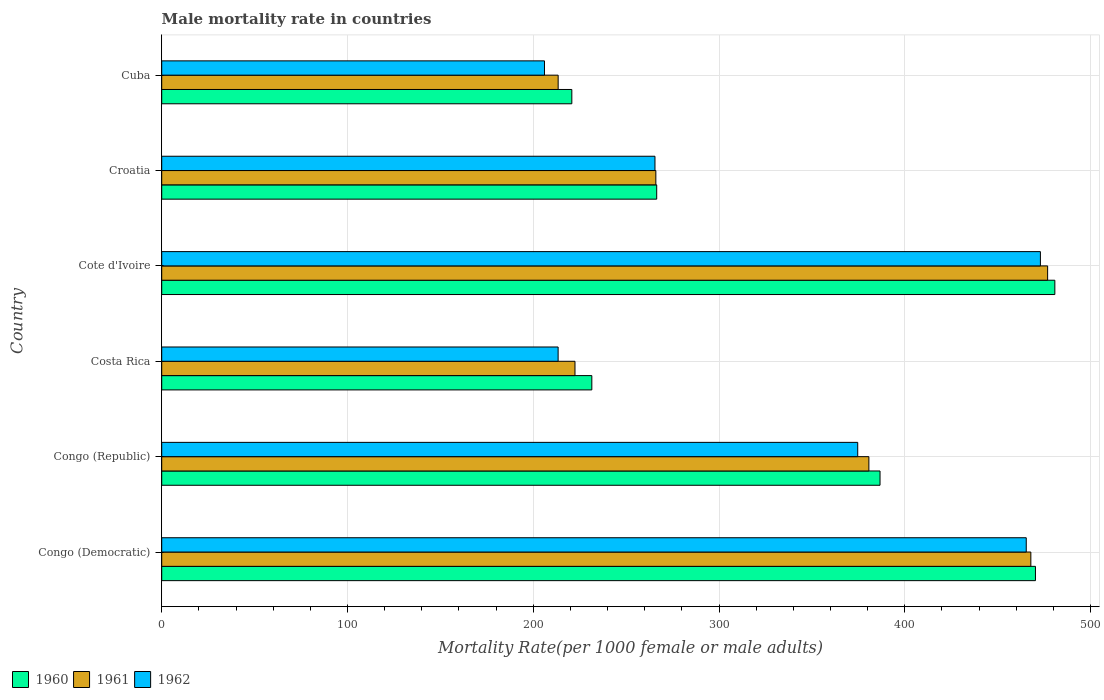How many groups of bars are there?
Make the answer very short. 6. Are the number of bars per tick equal to the number of legend labels?
Your answer should be very brief. Yes. What is the label of the 5th group of bars from the top?
Make the answer very short. Congo (Republic). What is the male mortality rate in 1962 in Congo (Republic)?
Keep it short and to the point. 374.66. Across all countries, what is the maximum male mortality rate in 1961?
Ensure brevity in your answer.  476.88. Across all countries, what is the minimum male mortality rate in 1960?
Your answer should be very brief. 220.76. In which country was the male mortality rate in 1960 maximum?
Your answer should be compact. Cote d'Ivoire. In which country was the male mortality rate in 1960 minimum?
Offer a very short reply. Cuba. What is the total male mortality rate in 1960 in the graph?
Your answer should be very brief. 2056.51. What is the difference between the male mortality rate in 1960 in Congo (Democratic) and that in Congo (Republic)?
Make the answer very short. 83.66. What is the difference between the male mortality rate in 1961 in Cote d'Ivoire and the male mortality rate in 1962 in Costa Rica?
Your answer should be very brief. 263.49. What is the average male mortality rate in 1961 per country?
Make the answer very short. 337.87. What is the difference between the male mortality rate in 1960 and male mortality rate in 1961 in Congo (Democratic)?
Provide a succinct answer. 2.48. What is the ratio of the male mortality rate in 1960 in Congo (Republic) to that in Costa Rica?
Keep it short and to the point. 1.67. Is the difference between the male mortality rate in 1960 in Congo (Democratic) and Cote d'Ivoire greater than the difference between the male mortality rate in 1961 in Congo (Democratic) and Cote d'Ivoire?
Keep it short and to the point. No. What is the difference between the highest and the second highest male mortality rate in 1961?
Provide a succinct answer. 9.03. What is the difference between the highest and the lowest male mortality rate in 1962?
Keep it short and to the point. 266.95. In how many countries, is the male mortality rate in 1962 greater than the average male mortality rate in 1962 taken over all countries?
Your response must be concise. 3. What does the 3rd bar from the bottom in Congo (Democratic) represents?
Your answer should be compact. 1962. Is it the case that in every country, the sum of the male mortality rate in 1961 and male mortality rate in 1960 is greater than the male mortality rate in 1962?
Your answer should be compact. Yes. Does the graph contain grids?
Offer a very short reply. Yes. How many legend labels are there?
Offer a very short reply. 3. How are the legend labels stacked?
Your answer should be very brief. Horizontal. What is the title of the graph?
Your response must be concise. Male mortality rate in countries. Does "2010" appear as one of the legend labels in the graph?
Provide a succinct answer. No. What is the label or title of the X-axis?
Keep it short and to the point. Mortality Rate(per 1000 female or male adults). What is the Mortality Rate(per 1000 female or male adults) in 1960 in Congo (Democratic)?
Provide a succinct answer. 470.33. What is the Mortality Rate(per 1000 female or male adults) of 1961 in Congo (Democratic)?
Your answer should be compact. 467.85. What is the Mortality Rate(per 1000 female or male adults) in 1962 in Congo (Democratic)?
Give a very brief answer. 465.37. What is the Mortality Rate(per 1000 female or male adults) of 1960 in Congo (Republic)?
Ensure brevity in your answer.  386.67. What is the Mortality Rate(per 1000 female or male adults) in 1961 in Congo (Republic)?
Your response must be concise. 380.66. What is the Mortality Rate(per 1000 female or male adults) of 1962 in Congo (Republic)?
Give a very brief answer. 374.66. What is the Mortality Rate(per 1000 female or male adults) of 1960 in Costa Rica?
Offer a terse response. 231.53. What is the Mortality Rate(per 1000 female or male adults) of 1961 in Costa Rica?
Your answer should be very brief. 222.46. What is the Mortality Rate(per 1000 female or male adults) of 1962 in Costa Rica?
Offer a terse response. 213.38. What is the Mortality Rate(per 1000 female or male adults) of 1960 in Cote d'Ivoire?
Keep it short and to the point. 480.76. What is the Mortality Rate(per 1000 female or male adults) of 1961 in Cote d'Ivoire?
Your answer should be compact. 476.88. What is the Mortality Rate(per 1000 female or male adults) in 1962 in Cote d'Ivoire?
Ensure brevity in your answer.  473. What is the Mortality Rate(per 1000 female or male adults) in 1960 in Croatia?
Your response must be concise. 266.45. What is the Mortality Rate(per 1000 female or male adults) in 1961 in Croatia?
Give a very brief answer. 265.99. What is the Mortality Rate(per 1000 female or male adults) of 1962 in Croatia?
Your answer should be compact. 265.52. What is the Mortality Rate(per 1000 female or male adults) in 1960 in Cuba?
Provide a succinct answer. 220.76. What is the Mortality Rate(per 1000 female or male adults) of 1961 in Cuba?
Your answer should be very brief. 213.41. What is the Mortality Rate(per 1000 female or male adults) in 1962 in Cuba?
Make the answer very short. 206.05. Across all countries, what is the maximum Mortality Rate(per 1000 female or male adults) of 1960?
Offer a terse response. 480.76. Across all countries, what is the maximum Mortality Rate(per 1000 female or male adults) in 1961?
Your answer should be compact. 476.88. Across all countries, what is the maximum Mortality Rate(per 1000 female or male adults) in 1962?
Your answer should be compact. 473. Across all countries, what is the minimum Mortality Rate(per 1000 female or male adults) of 1960?
Give a very brief answer. 220.76. Across all countries, what is the minimum Mortality Rate(per 1000 female or male adults) of 1961?
Make the answer very short. 213.41. Across all countries, what is the minimum Mortality Rate(per 1000 female or male adults) in 1962?
Keep it short and to the point. 206.05. What is the total Mortality Rate(per 1000 female or male adults) in 1960 in the graph?
Your answer should be compact. 2056.51. What is the total Mortality Rate(per 1000 female or male adults) in 1961 in the graph?
Your response must be concise. 2027.24. What is the total Mortality Rate(per 1000 female or male adults) of 1962 in the graph?
Your answer should be compact. 1997.98. What is the difference between the Mortality Rate(per 1000 female or male adults) in 1960 in Congo (Democratic) and that in Congo (Republic)?
Give a very brief answer. 83.66. What is the difference between the Mortality Rate(per 1000 female or male adults) in 1961 in Congo (Democratic) and that in Congo (Republic)?
Give a very brief answer. 87.19. What is the difference between the Mortality Rate(per 1000 female or male adults) in 1962 in Congo (Democratic) and that in Congo (Republic)?
Your answer should be very brief. 90.71. What is the difference between the Mortality Rate(per 1000 female or male adults) in 1960 in Congo (Democratic) and that in Costa Rica?
Provide a succinct answer. 238.8. What is the difference between the Mortality Rate(per 1000 female or male adults) in 1961 in Congo (Democratic) and that in Costa Rica?
Offer a very short reply. 245.39. What is the difference between the Mortality Rate(per 1000 female or male adults) in 1962 in Congo (Democratic) and that in Costa Rica?
Make the answer very short. 251.99. What is the difference between the Mortality Rate(per 1000 female or male adults) of 1960 in Congo (Democratic) and that in Cote d'Ivoire?
Keep it short and to the point. -10.43. What is the difference between the Mortality Rate(per 1000 female or male adults) in 1961 in Congo (Democratic) and that in Cote d'Ivoire?
Provide a short and direct response. -9.03. What is the difference between the Mortality Rate(per 1000 female or male adults) in 1962 in Congo (Democratic) and that in Cote d'Ivoire?
Your answer should be very brief. -7.62. What is the difference between the Mortality Rate(per 1000 female or male adults) in 1960 in Congo (Democratic) and that in Croatia?
Make the answer very short. 203.88. What is the difference between the Mortality Rate(per 1000 female or male adults) in 1961 in Congo (Democratic) and that in Croatia?
Give a very brief answer. 201.87. What is the difference between the Mortality Rate(per 1000 female or male adults) in 1962 in Congo (Democratic) and that in Croatia?
Ensure brevity in your answer.  199.85. What is the difference between the Mortality Rate(per 1000 female or male adults) in 1960 in Congo (Democratic) and that in Cuba?
Your response must be concise. 249.57. What is the difference between the Mortality Rate(per 1000 female or male adults) in 1961 in Congo (Democratic) and that in Cuba?
Your answer should be very brief. 254.45. What is the difference between the Mortality Rate(per 1000 female or male adults) in 1962 in Congo (Democratic) and that in Cuba?
Make the answer very short. 259.32. What is the difference between the Mortality Rate(per 1000 female or male adults) in 1960 in Congo (Republic) and that in Costa Rica?
Your answer should be compact. 155.14. What is the difference between the Mortality Rate(per 1000 female or male adults) of 1961 in Congo (Republic) and that in Costa Rica?
Provide a succinct answer. 158.21. What is the difference between the Mortality Rate(per 1000 female or male adults) in 1962 in Congo (Republic) and that in Costa Rica?
Ensure brevity in your answer.  161.28. What is the difference between the Mortality Rate(per 1000 female or male adults) in 1960 in Congo (Republic) and that in Cote d'Ivoire?
Give a very brief answer. -94.09. What is the difference between the Mortality Rate(per 1000 female or male adults) in 1961 in Congo (Republic) and that in Cote d'Ivoire?
Your answer should be compact. -96.22. What is the difference between the Mortality Rate(per 1000 female or male adults) in 1962 in Congo (Republic) and that in Cote d'Ivoire?
Give a very brief answer. -98.34. What is the difference between the Mortality Rate(per 1000 female or male adults) of 1960 in Congo (Republic) and that in Croatia?
Provide a succinct answer. 120.21. What is the difference between the Mortality Rate(per 1000 female or male adults) in 1961 in Congo (Republic) and that in Croatia?
Offer a very short reply. 114.68. What is the difference between the Mortality Rate(per 1000 female or male adults) in 1962 in Congo (Republic) and that in Croatia?
Your response must be concise. 109.14. What is the difference between the Mortality Rate(per 1000 female or male adults) in 1960 in Congo (Republic) and that in Cuba?
Offer a terse response. 165.91. What is the difference between the Mortality Rate(per 1000 female or male adults) of 1961 in Congo (Republic) and that in Cuba?
Give a very brief answer. 167.26. What is the difference between the Mortality Rate(per 1000 female or male adults) in 1962 in Congo (Republic) and that in Cuba?
Your answer should be compact. 168.61. What is the difference between the Mortality Rate(per 1000 female or male adults) of 1960 in Costa Rica and that in Cote d'Ivoire?
Make the answer very short. -249.23. What is the difference between the Mortality Rate(per 1000 female or male adults) of 1961 in Costa Rica and that in Cote d'Ivoire?
Keep it short and to the point. -254.42. What is the difference between the Mortality Rate(per 1000 female or male adults) in 1962 in Costa Rica and that in Cote d'Ivoire?
Offer a terse response. -259.61. What is the difference between the Mortality Rate(per 1000 female or male adults) in 1960 in Costa Rica and that in Croatia?
Provide a succinct answer. -34.92. What is the difference between the Mortality Rate(per 1000 female or male adults) in 1961 in Costa Rica and that in Croatia?
Your answer should be very brief. -43.53. What is the difference between the Mortality Rate(per 1000 female or male adults) in 1962 in Costa Rica and that in Croatia?
Offer a very short reply. -52.13. What is the difference between the Mortality Rate(per 1000 female or male adults) of 1960 in Costa Rica and that in Cuba?
Keep it short and to the point. 10.77. What is the difference between the Mortality Rate(per 1000 female or male adults) in 1961 in Costa Rica and that in Cuba?
Give a very brief answer. 9.05. What is the difference between the Mortality Rate(per 1000 female or male adults) of 1962 in Costa Rica and that in Cuba?
Make the answer very short. 7.34. What is the difference between the Mortality Rate(per 1000 female or male adults) of 1960 in Cote d'Ivoire and that in Croatia?
Offer a terse response. 214.31. What is the difference between the Mortality Rate(per 1000 female or male adults) of 1961 in Cote d'Ivoire and that in Croatia?
Your answer should be compact. 210.89. What is the difference between the Mortality Rate(per 1000 female or male adults) of 1962 in Cote d'Ivoire and that in Croatia?
Your answer should be compact. 207.48. What is the difference between the Mortality Rate(per 1000 female or male adults) in 1960 in Cote d'Ivoire and that in Cuba?
Offer a terse response. 260. What is the difference between the Mortality Rate(per 1000 female or male adults) of 1961 in Cote d'Ivoire and that in Cuba?
Make the answer very short. 263.47. What is the difference between the Mortality Rate(per 1000 female or male adults) of 1962 in Cote d'Ivoire and that in Cuba?
Your answer should be compact. 266.95. What is the difference between the Mortality Rate(per 1000 female or male adults) of 1960 in Croatia and that in Cuba?
Your answer should be compact. 45.69. What is the difference between the Mortality Rate(per 1000 female or male adults) of 1961 in Croatia and that in Cuba?
Provide a succinct answer. 52.58. What is the difference between the Mortality Rate(per 1000 female or male adults) of 1962 in Croatia and that in Cuba?
Ensure brevity in your answer.  59.47. What is the difference between the Mortality Rate(per 1000 female or male adults) of 1960 in Congo (Democratic) and the Mortality Rate(per 1000 female or male adults) of 1961 in Congo (Republic)?
Your answer should be very brief. 89.67. What is the difference between the Mortality Rate(per 1000 female or male adults) of 1960 in Congo (Democratic) and the Mortality Rate(per 1000 female or male adults) of 1962 in Congo (Republic)?
Provide a succinct answer. 95.67. What is the difference between the Mortality Rate(per 1000 female or male adults) of 1961 in Congo (Democratic) and the Mortality Rate(per 1000 female or male adults) of 1962 in Congo (Republic)?
Provide a succinct answer. 93.19. What is the difference between the Mortality Rate(per 1000 female or male adults) in 1960 in Congo (Democratic) and the Mortality Rate(per 1000 female or male adults) in 1961 in Costa Rica?
Your answer should be compact. 247.87. What is the difference between the Mortality Rate(per 1000 female or male adults) in 1960 in Congo (Democratic) and the Mortality Rate(per 1000 female or male adults) in 1962 in Costa Rica?
Your response must be concise. 256.94. What is the difference between the Mortality Rate(per 1000 female or male adults) of 1961 in Congo (Democratic) and the Mortality Rate(per 1000 female or male adults) of 1962 in Costa Rica?
Your answer should be very brief. 254.47. What is the difference between the Mortality Rate(per 1000 female or male adults) of 1960 in Congo (Democratic) and the Mortality Rate(per 1000 female or male adults) of 1961 in Cote d'Ivoire?
Keep it short and to the point. -6.55. What is the difference between the Mortality Rate(per 1000 female or male adults) of 1960 in Congo (Democratic) and the Mortality Rate(per 1000 female or male adults) of 1962 in Cote d'Ivoire?
Provide a succinct answer. -2.67. What is the difference between the Mortality Rate(per 1000 female or male adults) of 1961 in Congo (Democratic) and the Mortality Rate(per 1000 female or male adults) of 1962 in Cote d'Ivoire?
Your response must be concise. -5.14. What is the difference between the Mortality Rate(per 1000 female or male adults) in 1960 in Congo (Democratic) and the Mortality Rate(per 1000 female or male adults) in 1961 in Croatia?
Make the answer very short. 204.34. What is the difference between the Mortality Rate(per 1000 female or male adults) in 1960 in Congo (Democratic) and the Mortality Rate(per 1000 female or male adults) in 1962 in Croatia?
Offer a very short reply. 204.81. What is the difference between the Mortality Rate(per 1000 female or male adults) in 1961 in Congo (Democratic) and the Mortality Rate(per 1000 female or male adults) in 1962 in Croatia?
Your answer should be very brief. 202.33. What is the difference between the Mortality Rate(per 1000 female or male adults) in 1960 in Congo (Democratic) and the Mortality Rate(per 1000 female or male adults) in 1961 in Cuba?
Offer a very short reply. 256.93. What is the difference between the Mortality Rate(per 1000 female or male adults) in 1960 in Congo (Democratic) and the Mortality Rate(per 1000 female or male adults) in 1962 in Cuba?
Offer a terse response. 264.28. What is the difference between the Mortality Rate(per 1000 female or male adults) in 1961 in Congo (Democratic) and the Mortality Rate(per 1000 female or male adults) in 1962 in Cuba?
Give a very brief answer. 261.8. What is the difference between the Mortality Rate(per 1000 female or male adults) of 1960 in Congo (Republic) and the Mortality Rate(per 1000 female or male adults) of 1961 in Costa Rica?
Your answer should be very brief. 164.21. What is the difference between the Mortality Rate(per 1000 female or male adults) in 1960 in Congo (Republic) and the Mortality Rate(per 1000 female or male adults) in 1962 in Costa Rica?
Offer a terse response. 173.28. What is the difference between the Mortality Rate(per 1000 female or male adults) of 1961 in Congo (Republic) and the Mortality Rate(per 1000 female or male adults) of 1962 in Costa Rica?
Provide a succinct answer. 167.28. What is the difference between the Mortality Rate(per 1000 female or male adults) in 1960 in Congo (Republic) and the Mortality Rate(per 1000 female or male adults) in 1961 in Cote d'Ivoire?
Ensure brevity in your answer.  -90.21. What is the difference between the Mortality Rate(per 1000 female or male adults) in 1960 in Congo (Republic) and the Mortality Rate(per 1000 female or male adults) in 1962 in Cote d'Ivoire?
Provide a succinct answer. -86.33. What is the difference between the Mortality Rate(per 1000 female or male adults) in 1961 in Congo (Republic) and the Mortality Rate(per 1000 female or male adults) in 1962 in Cote d'Ivoire?
Your answer should be compact. -92.33. What is the difference between the Mortality Rate(per 1000 female or male adults) in 1960 in Congo (Republic) and the Mortality Rate(per 1000 female or male adults) in 1961 in Croatia?
Offer a very short reply. 120.68. What is the difference between the Mortality Rate(per 1000 female or male adults) in 1960 in Congo (Republic) and the Mortality Rate(per 1000 female or male adults) in 1962 in Croatia?
Provide a succinct answer. 121.15. What is the difference between the Mortality Rate(per 1000 female or male adults) in 1961 in Congo (Republic) and the Mortality Rate(per 1000 female or male adults) in 1962 in Croatia?
Offer a terse response. 115.15. What is the difference between the Mortality Rate(per 1000 female or male adults) in 1960 in Congo (Republic) and the Mortality Rate(per 1000 female or male adults) in 1961 in Cuba?
Your response must be concise. 173.26. What is the difference between the Mortality Rate(per 1000 female or male adults) of 1960 in Congo (Republic) and the Mortality Rate(per 1000 female or male adults) of 1962 in Cuba?
Offer a very short reply. 180.62. What is the difference between the Mortality Rate(per 1000 female or male adults) in 1961 in Congo (Republic) and the Mortality Rate(per 1000 female or male adults) in 1962 in Cuba?
Ensure brevity in your answer.  174.62. What is the difference between the Mortality Rate(per 1000 female or male adults) of 1960 in Costa Rica and the Mortality Rate(per 1000 female or male adults) of 1961 in Cote d'Ivoire?
Ensure brevity in your answer.  -245.35. What is the difference between the Mortality Rate(per 1000 female or male adults) of 1960 in Costa Rica and the Mortality Rate(per 1000 female or male adults) of 1962 in Cote d'Ivoire?
Your response must be concise. -241.46. What is the difference between the Mortality Rate(per 1000 female or male adults) in 1961 in Costa Rica and the Mortality Rate(per 1000 female or male adults) in 1962 in Cote d'Ivoire?
Provide a succinct answer. -250.54. What is the difference between the Mortality Rate(per 1000 female or male adults) of 1960 in Costa Rica and the Mortality Rate(per 1000 female or male adults) of 1961 in Croatia?
Offer a very short reply. -34.45. What is the difference between the Mortality Rate(per 1000 female or male adults) in 1960 in Costa Rica and the Mortality Rate(per 1000 female or male adults) in 1962 in Croatia?
Provide a short and direct response. -33.98. What is the difference between the Mortality Rate(per 1000 female or male adults) of 1961 in Costa Rica and the Mortality Rate(per 1000 female or male adults) of 1962 in Croatia?
Your answer should be very brief. -43.06. What is the difference between the Mortality Rate(per 1000 female or male adults) in 1960 in Costa Rica and the Mortality Rate(per 1000 female or male adults) in 1961 in Cuba?
Your answer should be very brief. 18.13. What is the difference between the Mortality Rate(per 1000 female or male adults) of 1960 in Costa Rica and the Mortality Rate(per 1000 female or male adults) of 1962 in Cuba?
Ensure brevity in your answer.  25.49. What is the difference between the Mortality Rate(per 1000 female or male adults) of 1961 in Costa Rica and the Mortality Rate(per 1000 female or male adults) of 1962 in Cuba?
Ensure brevity in your answer.  16.41. What is the difference between the Mortality Rate(per 1000 female or male adults) in 1960 in Cote d'Ivoire and the Mortality Rate(per 1000 female or male adults) in 1961 in Croatia?
Ensure brevity in your answer.  214.78. What is the difference between the Mortality Rate(per 1000 female or male adults) in 1960 in Cote d'Ivoire and the Mortality Rate(per 1000 female or male adults) in 1962 in Croatia?
Ensure brevity in your answer.  215.25. What is the difference between the Mortality Rate(per 1000 female or male adults) of 1961 in Cote d'Ivoire and the Mortality Rate(per 1000 female or male adults) of 1962 in Croatia?
Provide a succinct answer. 211.36. What is the difference between the Mortality Rate(per 1000 female or male adults) of 1960 in Cote d'Ivoire and the Mortality Rate(per 1000 female or male adults) of 1961 in Cuba?
Make the answer very short. 267.36. What is the difference between the Mortality Rate(per 1000 female or male adults) of 1960 in Cote d'Ivoire and the Mortality Rate(per 1000 female or male adults) of 1962 in Cuba?
Your response must be concise. 274.72. What is the difference between the Mortality Rate(per 1000 female or male adults) of 1961 in Cote d'Ivoire and the Mortality Rate(per 1000 female or male adults) of 1962 in Cuba?
Give a very brief answer. 270.83. What is the difference between the Mortality Rate(per 1000 female or male adults) in 1960 in Croatia and the Mortality Rate(per 1000 female or male adults) in 1961 in Cuba?
Give a very brief answer. 53.05. What is the difference between the Mortality Rate(per 1000 female or male adults) of 1960 in Croatia and the Mortality Rate(per 1000 female or male adults) of 1962 in Cuba?
Your answer should be compact. 60.41. What is the difference between the Mortality Rate(per 1000 female or male adults) in 1961 in Croatia and the Mortality Rate(per 1000 female or male adults) in 1962 in Cuba?
Offer a terse response. 59.94. What is the average Mortality Rate(per 1000 female or male adults) of 1960 per country?
Ensure brevity in your answer.  342.75. What is the average Mortality Rate(per 1000 female or male adults) in 1961 per country?
Keep it short and to the point. 337.87. What is the average Mortality Rate(per 1000 female or male adults) of 1962 per country?
Your response must be concise. 333. What is the difference between the Mortality Rate(per 1000 female or male adults) of 1960 and Mortality Rate(per 1000 female or male adults) of 1961 in Congo (Democratic)?
Your response must be concise. 2.48. What is the difference between the Mortality Rate(per 1000 female or male adults) of 1960 and Mortality Rate(per 1000 female or male adults) of 1962 in Congo (Democratic)?
Offer a terse response. 4.96. What is the difference between the Mortality Rate(per 1000 female or male adults) of 1961 and Mortality Rate(per 1000 female or male adults) of 1962 in Congo (Democratic)?
Ensure brevity in your answer.  2.48. What is the difference between the Mortality Rate(per 1000 female or male adults) of 1960 and Mortality Rate(per 1000 female or male adults) of 1961 in Congo (Republic)?
Your answer should be compact. 6. What is the difference between the Mortality Rate(per 1000 female or male adults) of 1960 and Mortality Rate(per 1000 female or male adults) of 1962 in Congo (Republic)?
Keep it short and to the point. 12.01. What is the difference between the Mortality Rate(per 1000 female or male adults) in 1961 and Mortality Rate(per 1000 female or male adults) in 1962 in Congo (Republic)?
Your answer should be very brief. 6. What is the difference between the Mortality Rate(per 1000 female or male adults) in 1960 and Mortality Rate(per 1000 female or male adults) in 1961 in Costa Rica?
Offer a terse response. 9.07. What is the difference between the Mortality Rate(per 1000 female or male adults) of 1960 and Mortality Rate(per 1000 female or male adults) of 1962 in Costa Rica?
Give a very brief answer. 18.15. What is the difference between the Mortality Rate(per 1000 female or male adults) of 1961 and Mortality Rate(per 1000 female or male adults) of 1962 in Costa Rica?
Ensure brevity in your answer.  9.07. What is the difference between the Mortality Rate(per 1000 female or male adults) of 1960 and Mortality Rate(per 1000 female or male adults) of 1961 in Cote d'Ivoire?
Your answer should be compact. 3.88. What is the difference between the Mortality Rate(per 1000 female or male adults) in 1960 and Mortality Rate(per 1000 female or male adults) in 1962 in Cote d'Ivoire?
Provide a short and direct response. 7.77. What is the difference between the Mortality Rate(per 1000 female or male adults) of 1961 and Mortality Rate(per 1000 female or male adults) of 1962 in Cote d'Ivoire?
Your response must be concise. 3.88. What is the difference between the Mortality Rate(per 1000 female or male adults) of 1960 and Mortality Rate(per 1000 female or male adults) of 1961 in Croatia?
Your answer should be very brief. 0.47. What is the difference between the Mortality Rate(per 1000 female or male adults) in 1960 and Mortality Rate(per 1000 female or male adults) in 1962 in Croatia?
Provide a succinct answer. 0.94. What is the difference between the Mortality Rate(per 1000 female or male adults) in 1961 and Mortality Rate(per 1000 female or male adults) in 1962 in Croatia?
Ensure brevity in your answer.  0.47. What is the difference between the Mortality Rate(per 1000 female or male adults) in 1960 and Mortality Rate(per 1000 female or male adults) in 1961 in Cuba?
Your answer should be compact. 7.36. What is the difference between the Mortality Rate(per 1000 female or male adults) in 1960 and Mortality Rate(per 1000 female or male adults) in 1962 in Cuba?
Your response must be concise. 14.72. What is the difference between the Mortality Rate(per 1000 female or male adults) in 1961 and Mortality Rate(per 1000 female or male adults) in 1962 in Cuba?
Your answer should be compact. 7.36. What is the ratio of the Mortality Rate(per 1000 female or male adults) in 1960 in Congo (Democratic) to that in Congo (Republic)?
Provide a succinct answer. 1.22. What is the ratio of the Mortality Rate(per 1000 female or male adults) of 1961 in Congo (Democratic) to that in Congo (Republic)?
Offer a terse response. 1.23. What is the ratio of the Mortality Rate(per 1000 female or male adults) of 1962 in Congo (Democratic) to that in Congo (Republic)?
Provide a succinct answer. 1.24. What is the ratio of the Mortality Rate(per 1000 female or male adults) in 1960 in Congo (Democratic) to that in Costa Rica?
Offer a very short reply. 2.03. What is the ratio of the Mortality Rate(per 1000 female or male adults) of 1961 in Congo (Democratic) to that in Costa Rica?
Offer a very short reply. 2.1. What is the ratio of the Mortality Rate(per 1000 female or male adults) of 1962 in Congo (Democratic) to that in Costa Rica?
Your response must be concise. 2.18. What is the ratio of the Mortality Rate(per 1000 female or male adults) of 1960 in Congo (Democratic) to that in Cote d'Ivoire?
Keep it short and to the point. 0.98. What is the ratio of the Mortality Rate(per 1000 female or male adults) in 1961 in Congo (Democratic) to that in Cote d'Ivoire?
Ensure brevity in your answer.  0.98. What is the ratio of the Mortality Rate(per 1000 female or male adults) of 1962 in Congo (Democratic) to that in Cote d'Ivoire?
Ensure brevity in your answer.  0.98. What is the ratio of the Mortality Rate(per 1000 female or male adults) in 1960 in Congo (Democratic) to that in Croatia?
Offer a terse response. 1.77. What is the ratio of the Mortality Rate(per 1000 female or male adults) of 1961 in Congo (Democratic) to that in Croatia?
Offer a terse response. 1.76. What is the ratio of the Mortality Rate(per 1000 female or male adults) of 1962 in Congo (Democratic) to that in Croatia?
Your answer should be compact. 1.75. What is the ratio of the Mortality Rate(per 1000 female or male adults) in 1960 in Congo (Democratic) to that in Cuba?
Provide a short and direct response. 2.13. What is the ratio of the Mortality Rate(per 1000 female or male adults) in 1961 in Congo (Democratic) to that in Cuba?
Ensure brevity in your answer.  2.19. What is the ratio of the Mortality Rate(per 1000 female or male adults) of 1962 in Congo (Democratic) to that in Cuba?
Offer a terse response. 2.26. What is the ratio of the Mortality Rate(per 1000 female or male adults) in 1960 in Congo (Republic) to that in Costa Rica?
Provide a short and direct response. 1.67. What is the ratio of the Mortality Rate(per 1000 female or male adults) of 1961 in Congo (Republic) to that in Costa Rica?
Your response must be concise. 1.71. What is the ratio of the Mortality Rate(per 1000 female or male adults) of 1962 in Congo (Republic) to that in Costa Rica?
Provide a short and direct response. 1.76. What is the ratio of the Mortality Rate(per 1000 female or male adults) in 1960 in Congo (Republic) to that in Cote d'Ivoire?
Offer a terse response. 0.8. What is the ratio of the Mortality Rate(per 1000 female or male adults) in 1961 in Congo (Republic) to that in Cote d'Ivoire?
Offer a terse response. 0.8. What is the ratio of the Mortality Rate(per 1000 female or male adults) of 1962 in Congo (Republic) to that in Cote d'Ivoire?
Make the answer very short. 0.79. What is the ratio of the Mortality Rate(per 1000 female or male adults) of 1960 in Congo (Republic) to that in Croatia?
Keep it short and to the point. 1.45. What is the ratio of the Mortality Rate(per 1000 female or male adults) in 1961 in Congo (Republic) to that in Croatia?
Make the answer very short. 1.43. What is the ratio of the Mortality Rate(per 1000 female or male adults) of 1962 in Congo (Republic) to that in Croatia?
Make the answer very short. 1.41. What is the ratio of the Mortality Rate(per 1000 female or male adults) of 1960 in Congo (Republic) to that in Cuba?
Keep it short and to the point. 1.75. What is the ratio of the Mortality Rate(per 1000 female or male adults) in 1961 in Congo (Republic) to that in Cuba?
Make the answer very short. 1.78. What is the ratio of the Mortality Rate(per 1000 female or male adults) of 1962 in Congo (Republic) to that in Cuba?
Make the answer very short. 1.82. What is the ratio of the Mortality Rate(per 1000 female or male adults) of 1960 in Costa Rica to that in Cote d'Ivoire?
Keep it short and to the point. 0.48. What is the ratio of the Mortality Rate(per 1000 female or male adults) of 1961 in Costa Rica to that in Cote d'Ivoire?
Offer a terse response. 0.47. What is the ratio of the Mortality Rate(per 1000 female or male adults) in 1962 in Costa Rica to that in Cote d'Ivoire?
Make the answer very short. 0.45. What is the ratio of the Mortality Rate(per 1000 female or male adults) of 1960 in Costa Rica to that in Croatia?
Your response must be concise. 0.87. What is the ratio of the Mortality Rate(per 1000 female or male adults) in 1961 in Costa Rica to that in Croatia?
Provide a short and direct response. 0.84. What is the ratio of the Mortality Rate(per 1000 female or male adults) in 1962 in Costa Rica to that in Croatia?
Make the answer very short. 0.8. What is the ratio of the Mortality Rate(per 1000 female or male adults) of 1960 in Costa Rica to that in Cuba?
Give a very brief answer. 1.05. What is the ratio of the Mortality Rate(per 1000 female or male adults) in 1961 in Costa Rica to that in Cuba?
Provide a short and direct response. 1.04. What is the ratio of the Mortality Rate(per 1000 female or male adults) in 1962 in Costa Rica to that in Cuba?
Ensure brevity in your answer.  1.04. What is the ratio of the Mortality Rate(per 1000 female or male adults) in 1960 in Cote d'Ivoire to that in Croatia?
Ensure brevity in your answer.  1.8. What is the ratio of the Mortality Rate(per 1000 female or male adults) in 1961 in Cote d'Ivoire to that in Croatia?
Give a very brief answer. 1.79. What is the ratio of the Mortality Rate(per 1000 female or male adults) of 1962 in Cote d'Ivoire to that in Croatia?
Ensure brevity in your answer.  1.78. What is the ratio of the Mortality Rate(per 1000 female or male adults) of 1960 in Cote d'Ivoire to that in Cuba?
Offer a very short reply. 2.18. What is the ratio of the Mortality Rate(per 1000 female or male adults) in 1961 in Cote d'Ivoire to that in Cuba?
Provide a succinct answer. 2.23. What is the ratio of the Mortality Rate(per 1000 female or male adults) of 1962 in Cote d'Ivoire to that in Cuba?
Give a very brief answer. 2.3. What is the ratio of the Mortality Rate(per 1000 female or male adults) in 1960 in Croatia to that in Cuba?
Your response must be concise. 1.21. What is the ratio of the Mortality Rate(per 1000 female or male adults) of 1961 in Croatia to that in Cuba?
Keep it short and to the point. 1.25. What is the ratio of the Mortality Rate(per 1000 female or male adults) in 1962 in Croatia to that in Cuba?
Provide a succinct answer. 1.29. What is the difference between the highest and the second highest Mortality Rate(per 1000 female or male adults) of 1960?
Give a very brief answer. 10.43. What is the difference between the highest and the second highest Mortality Rate(per 1000 female or male adults) in 1961?
Keep it short and to the point. 9.03. What is the difference between the highest and the second highest Mortality Rate(per 1000 female or male adults) in 1962?
Your response must be concise. 7.62. What is the difference between the highest and the lowest Mortality Rate(per 1000 female or male adults) of 1960?
Your response must be concise. 260. What is the difference between the highest and the lowest Mortality Rate(per 1000 female or male adults) of 1961?
Your answer should be compact. 263.47. What is the difference between the highest and the lowest Mortality Rate(per 1000 female or male adults) of 1962?
Offer a very short reply. 266.95. 